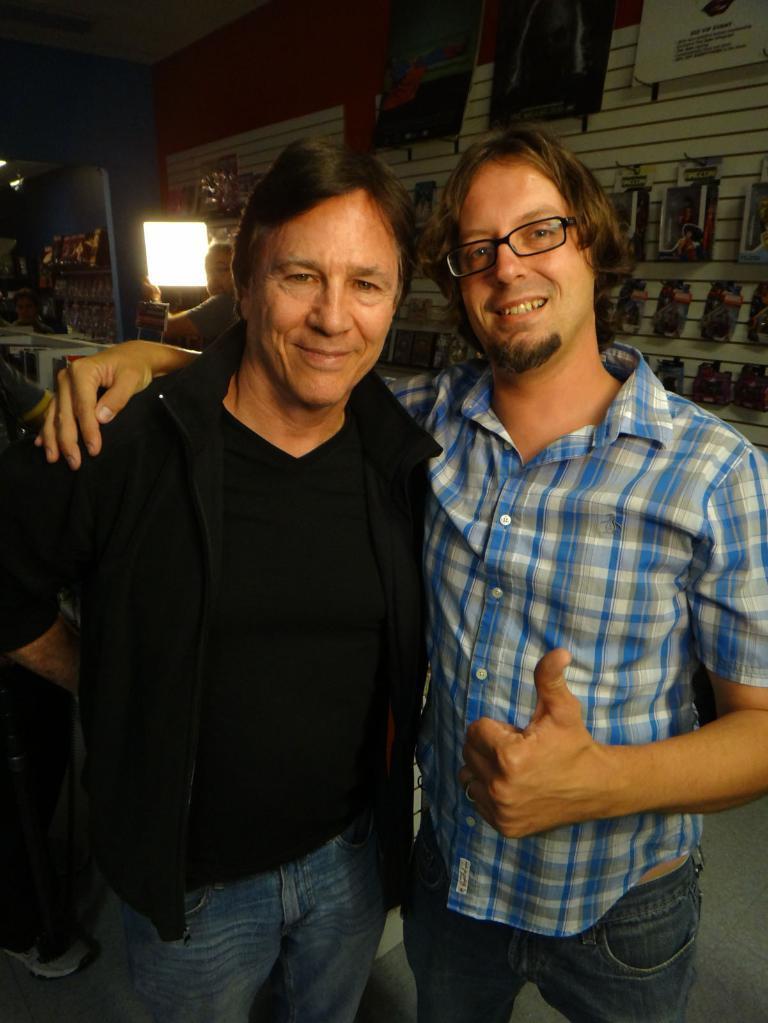Could you give a brief overview of what you see in this image? In this image we can see two persons standing, and behind them, we can see a wall. 